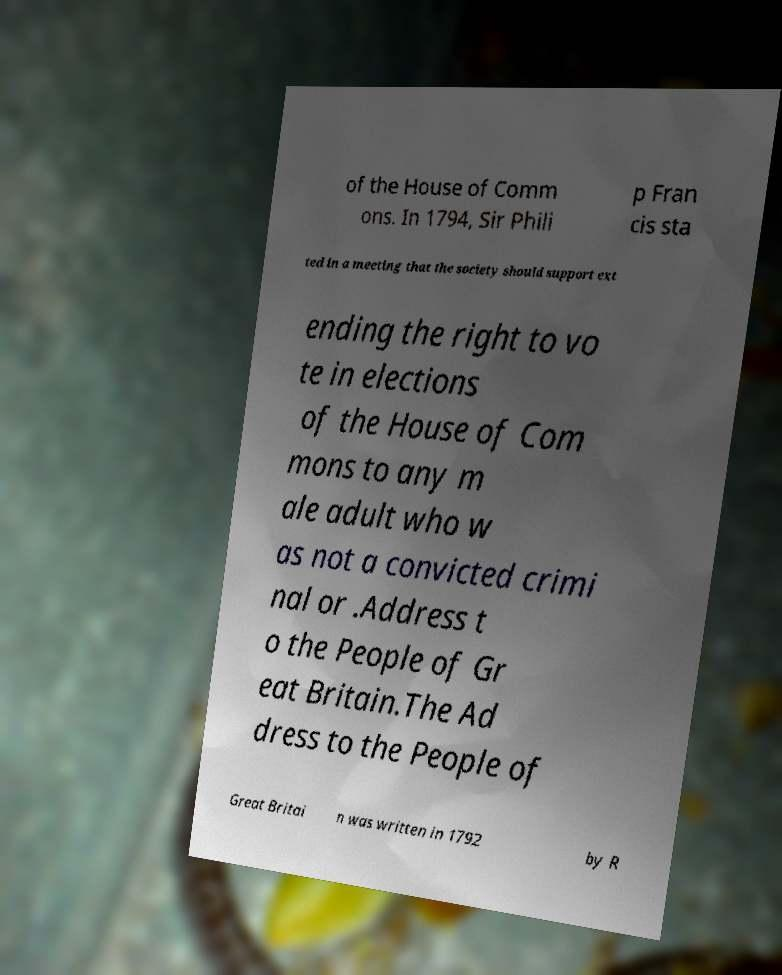Please identify and transcribe the text found in this image. of the House of Comm ons. In 1794, Sir Phili p Fran cis sta ted in a meeting that the society should support ext ending the right to vo te in elections of the House of Com mons to any m ale adult who w as not a convicted crimi nal or .Address t o the People of Gr eat Britain.The Ad dress to the People of Great Britai n was written in 1792 by R 